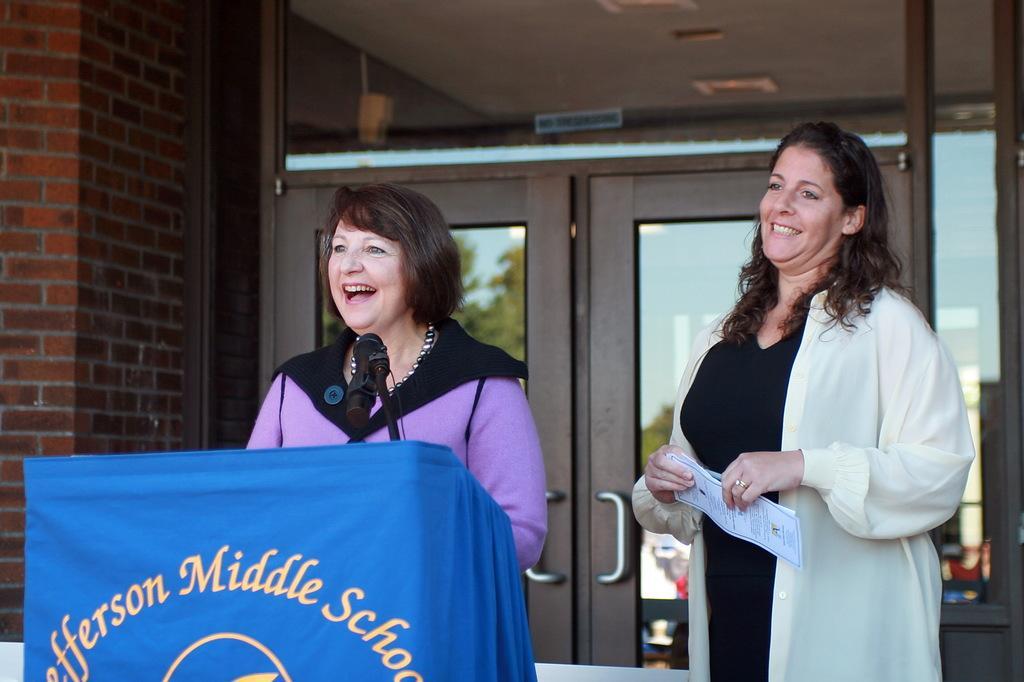Please provide a concise description of this image. In the picture we can see two women, woman wearing white and black color dress holding some paper in her hands and we can see another woman wearing pink color dress standing behind podium on which there is microphone and in the background there is glass door, on left side of the picture we can see brick wall. 